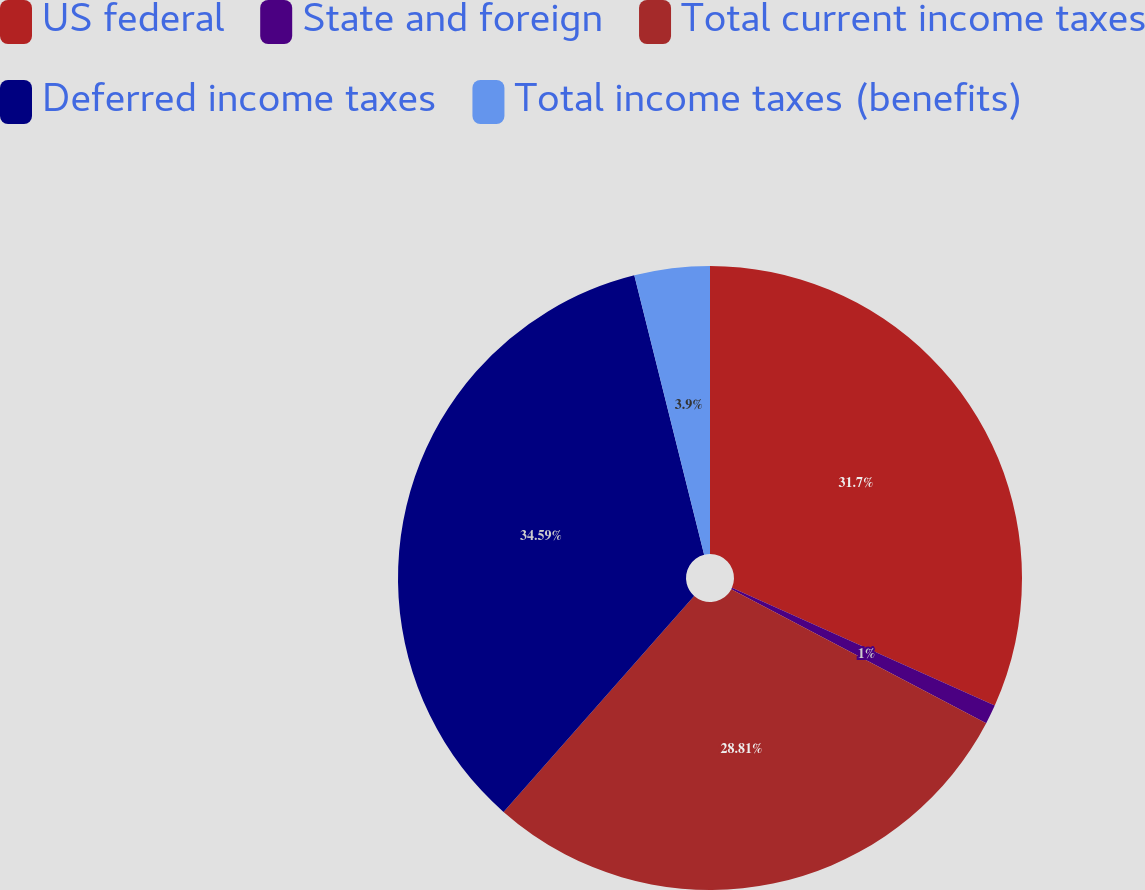<chart> <loc_0><loc_0><loc_500><loc_500><pie_chart><fcel>US federal<fcel>State and foreign<fcel>Total current income taxes<fcel>Deferred income taxes<fcel>Total income taxes (benefits)<nl><fcel>31.7%<fcel>1.0%<fcel>28.81%<fcel>34.59%<fcel>3.9%<nl></chart> 